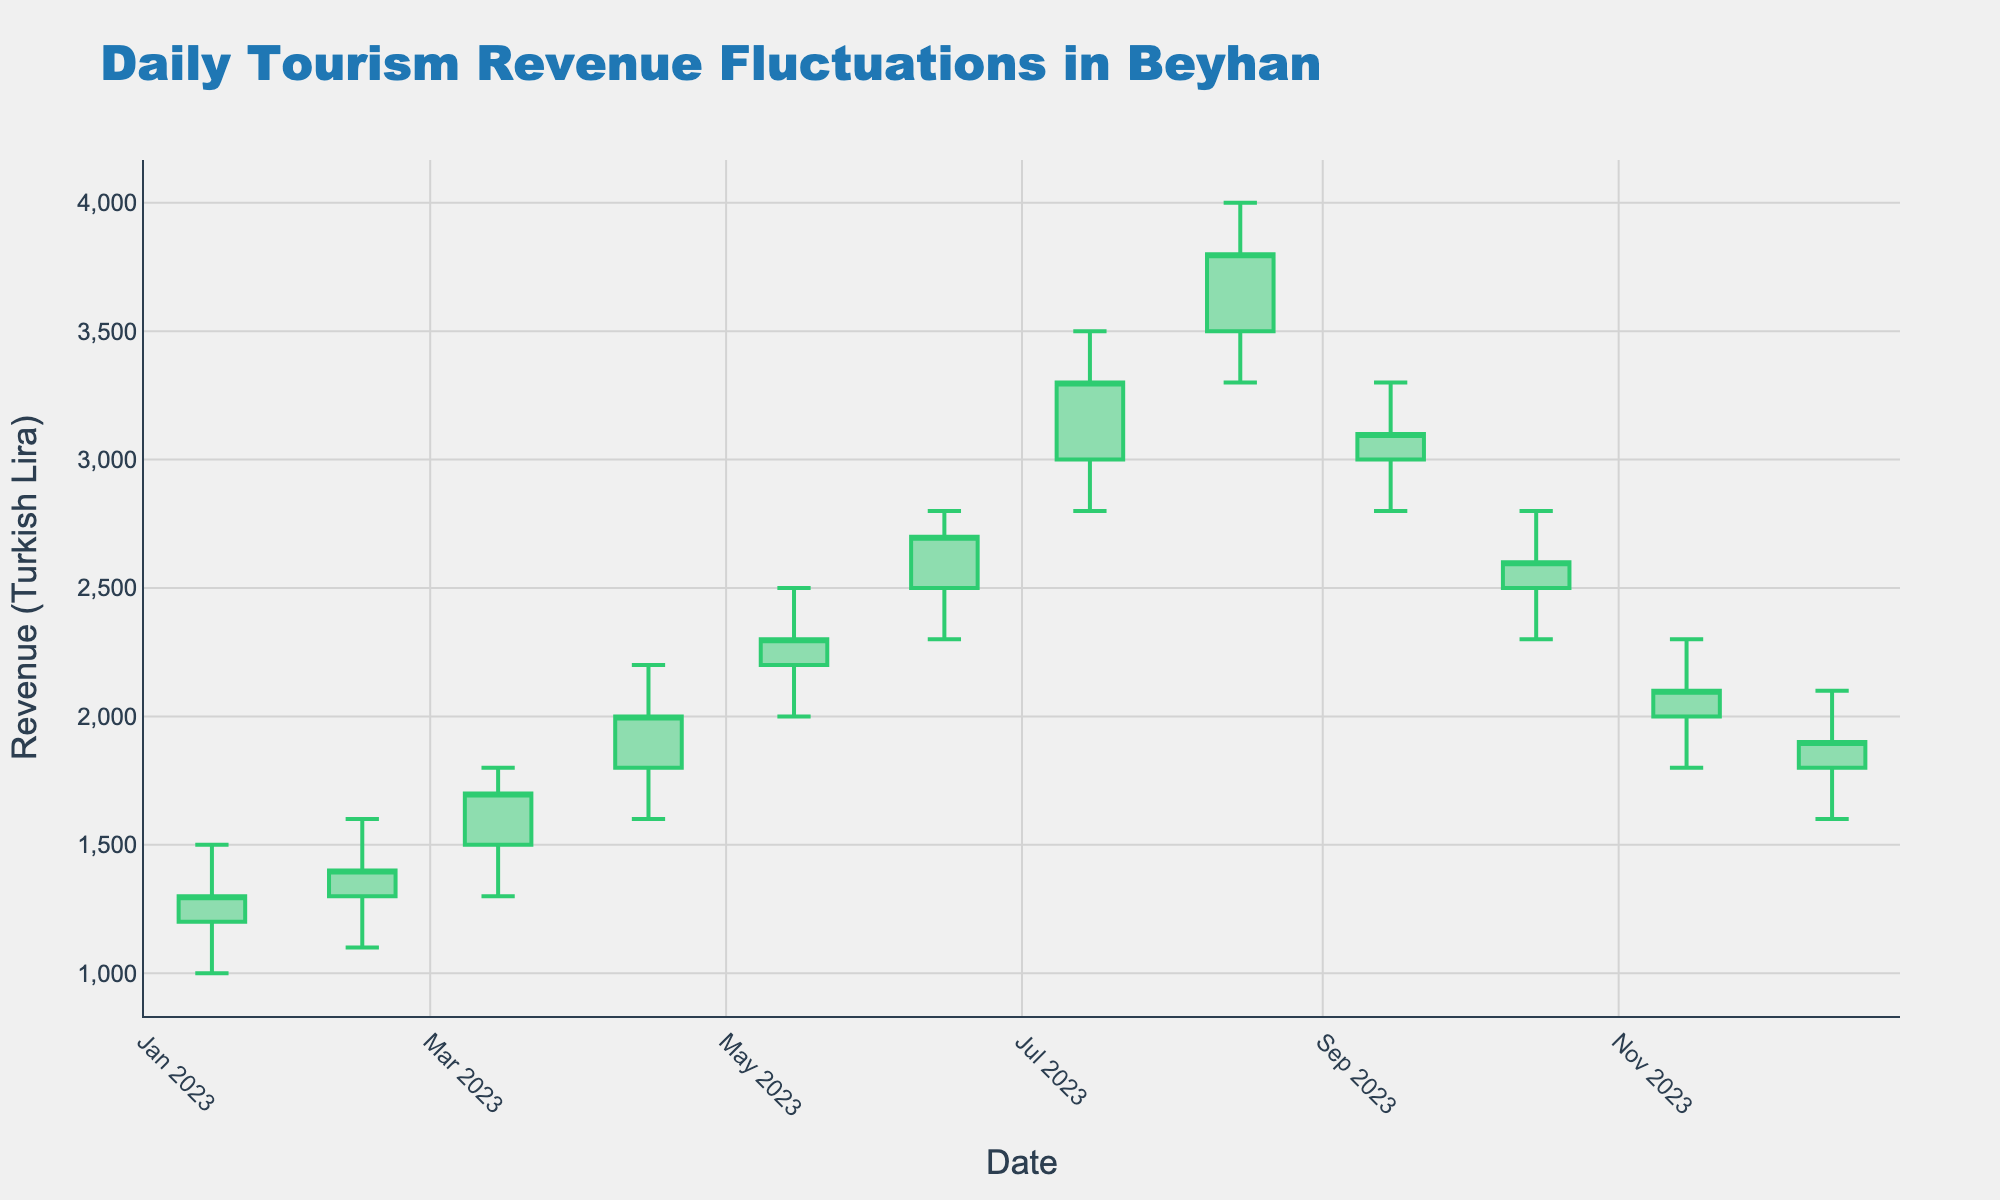what's the title of the chart? The title is usually located at the top of the chart. The title here is "Daily Tourism Revenue Fluctuations in Beyhan".
Answer: Daily Tourism Revenue Fluctuations in Beyhan how many data points (candlesticks) are shown in the chart? Each data point corresponds to a month and there are 12 candlesticks, one for each month of the year.
Answer: 12 what's the highest observed revenue in the figure? Check the highest point on the chart, which is represented by the upper shadow of the candlestick. The highest value is in August and is 4000 Turkish Lira.
Answer: 4000 Turkish Lira what's the lowest observed revenue in the figure? Check the lowest point on the chart, represented by the lower shadow of the candlestick. The lowest value is in January and is 1000 Turkish Lira.
Answer: 1000 Turkish Lira what's the difference between the opening revenue in January and the closing revenue in December? The opening revenue in January is 1200 and the closing revenue in December is 1900. The difference is 1900 - 1200 = 700.
Answer: 700 which month had the highest increase in revenue within the month? Look for the candlestick with the longest upper shadow, which indicates the highest range. August shows the highest increase within the month, from 3300 to 4000.
Answer: August how does the revenue in July compare to the revenue in October? In July, the closing revenue is 3300, and in October, it is 2600. Therefore, July's revenue is higher than October's by 700 Turkish Lira (3300 - 2600).
Answer: July's revenue is higher what's the average closing revenue for the first half of the year? Sum the closing revenues from January to June (1300 + 1400 + 1700 + 2000 + 2300 + 2700) and divide by 6. That is (11400) / 6 = 1900.
Answer: 1900 which months show a decrease in closing revenue compared to the previous month? Compare each month's closing revenue to the previous month's closing revenue. The months showing a decrease are September (3100 vs 3800 in August), October (2600 vs 3100 in September), November (2100 vs 2600 in October), and December (1900 vs 2100 in November).
Answer: September, October, November, December what's the closing revenue in March, and is it greater than the opening revenue in February? The closing revenue in March is 1700. The opening revenue in February is 1300. Since 1700 is greater than 1300, the answer is yes.
Answer: Yes 